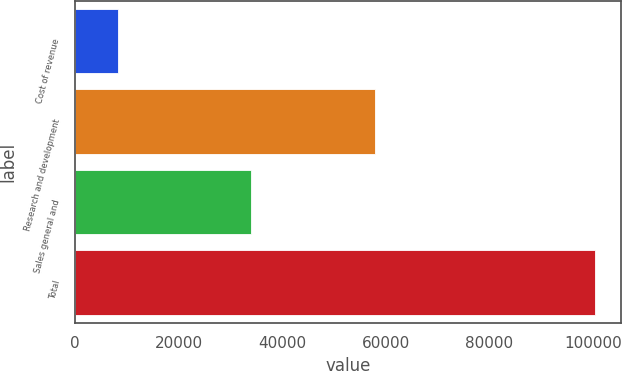Convert chart. <chart><loc_0><loc_0><loc_500><loc_500><bar_chart><fcel>Cost of revenue<fcel>Research and development<fcel>Sales general and<fcel>Total<nl><fcel>8308<fcel>57974<fcel>34071<fcel>100353<nl></chart> 